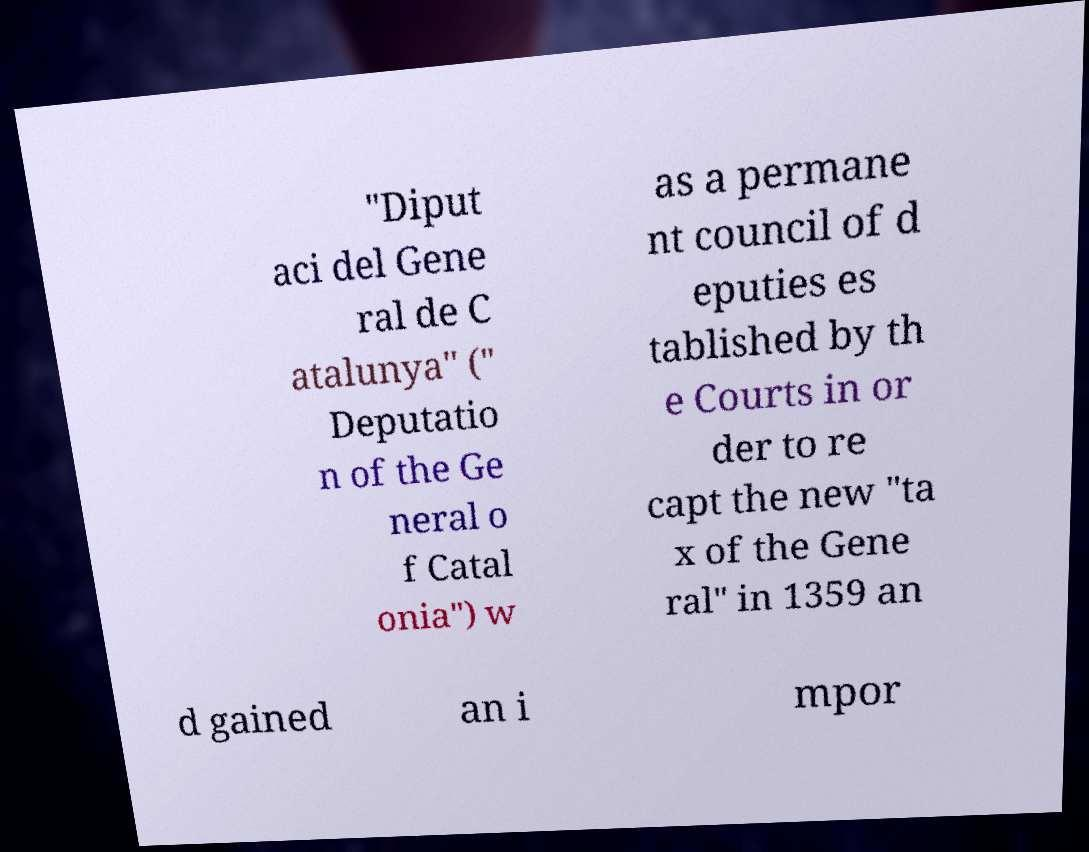For documentation purposes, I need the text within this image transcribed. Could you provide that? "Diput aci del Gene ral de C atalunya" (" Deputatio n of the Ge neral o f Catal onia") w as a permane nt council of d eputies es tablished by th e Courts in or der to re capt the new "ta x of the Gene ral" in 1359 an d gained an i mpor 